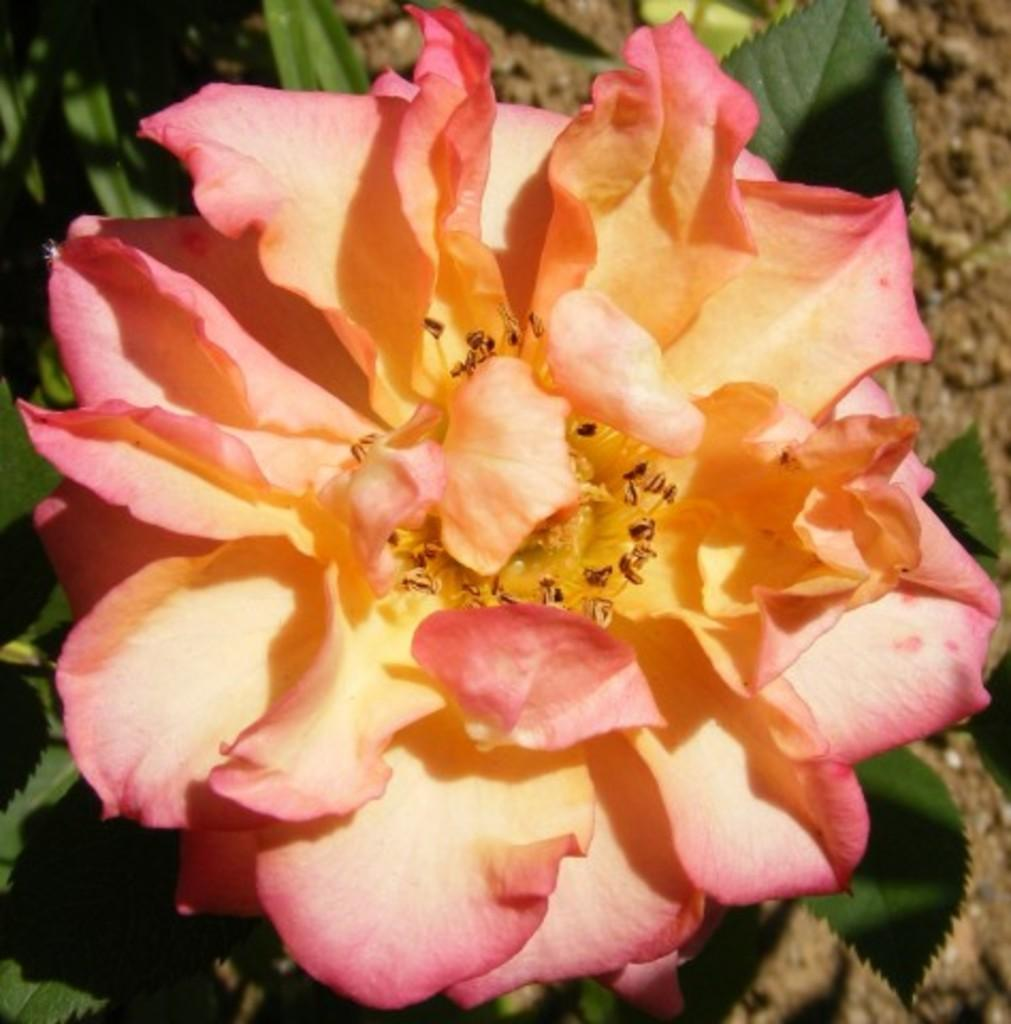What type of flower is in the image? There is a rose flower in the image. What colors are the metals in the image? The metals in the image are yellow and pinkish. What part of the rose flower is visible in the image? The stamen is visible in the image. What can be seen in the background of the image? There are leaves in the background of the image. What type of channel can be seen in the image? There is no channel present in the image; it features a rose flower, metals, and leaves. Is there a bomb visible in the image? No, there is no bomb present in the image. 